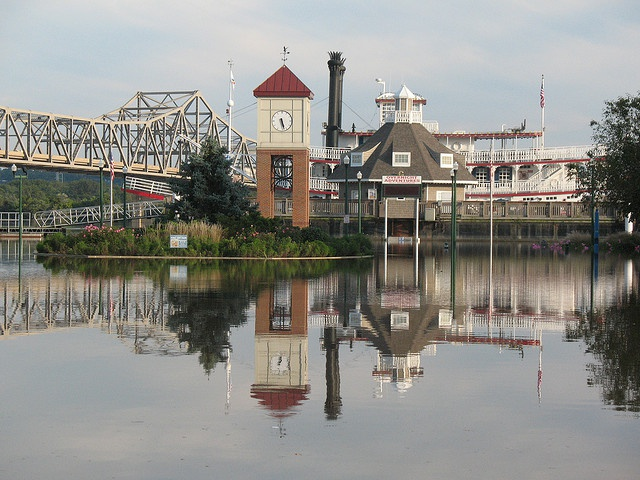Describe the objects in this image and their specific colors. I can see a clock in lightgray, darkgray, and gray tones in this image. 